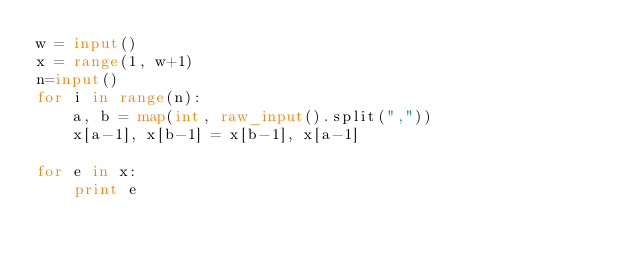Convert code to text. <code><loc_0><loc_0><loc_500><loc_500><_Python_>w = input()
x = range(1, w+1)
n=input()
for i in range(n):
    a, b = map(int, raw_input().split(","))
    x[a-1], x[b-1] = x[b-1], x[a-1]

for e in x:
    print e</code> 